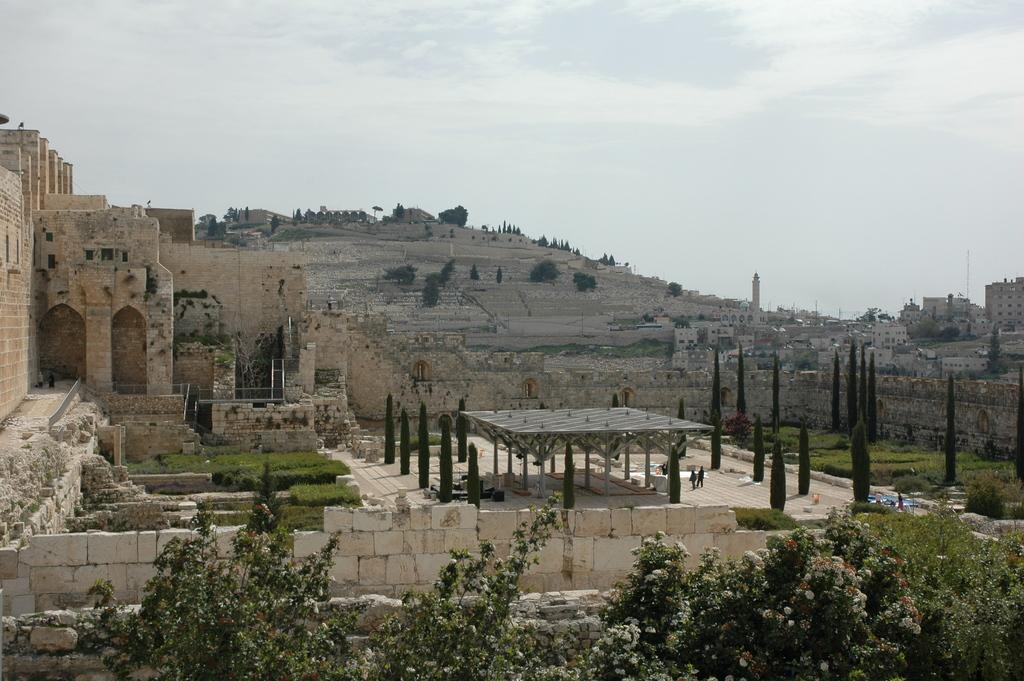What type of structures can be seen in the image? There are buildings and towers in the image. What type of vegetation is present in the image? There are trees and plants in the image. What is visible in the background of the image? The sky is visible in the image. What can be observed in the sky? Clouds are present in the sky. What direction are the buildings facing in the image? The direction the buildings are facing cannot be determined from the image. What type of friction can be observed between the plants and the ground in the image? There is no friction between the plants and the ground visible in the image. 